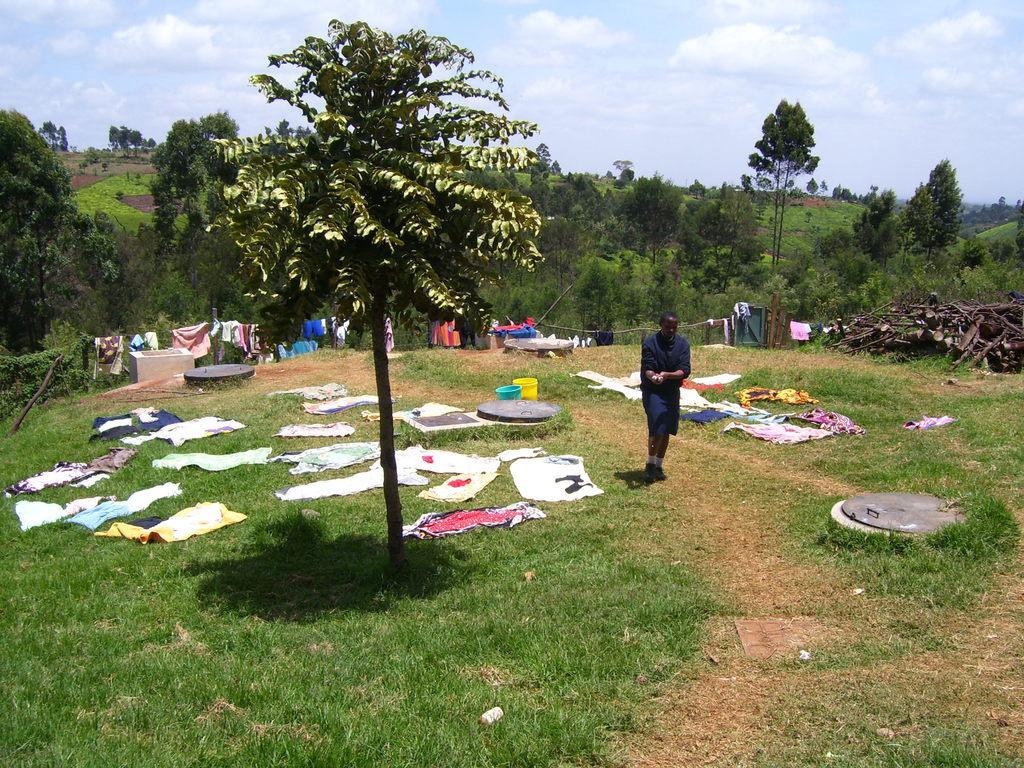How would you summarize this image in a sentence or two? In this image we can see a person wearing a dress is standing on the ground, group of clothes are placed on the ground. In the foreground we can see a tree and in the background, we can see a group of trees and the cloudy sky. 